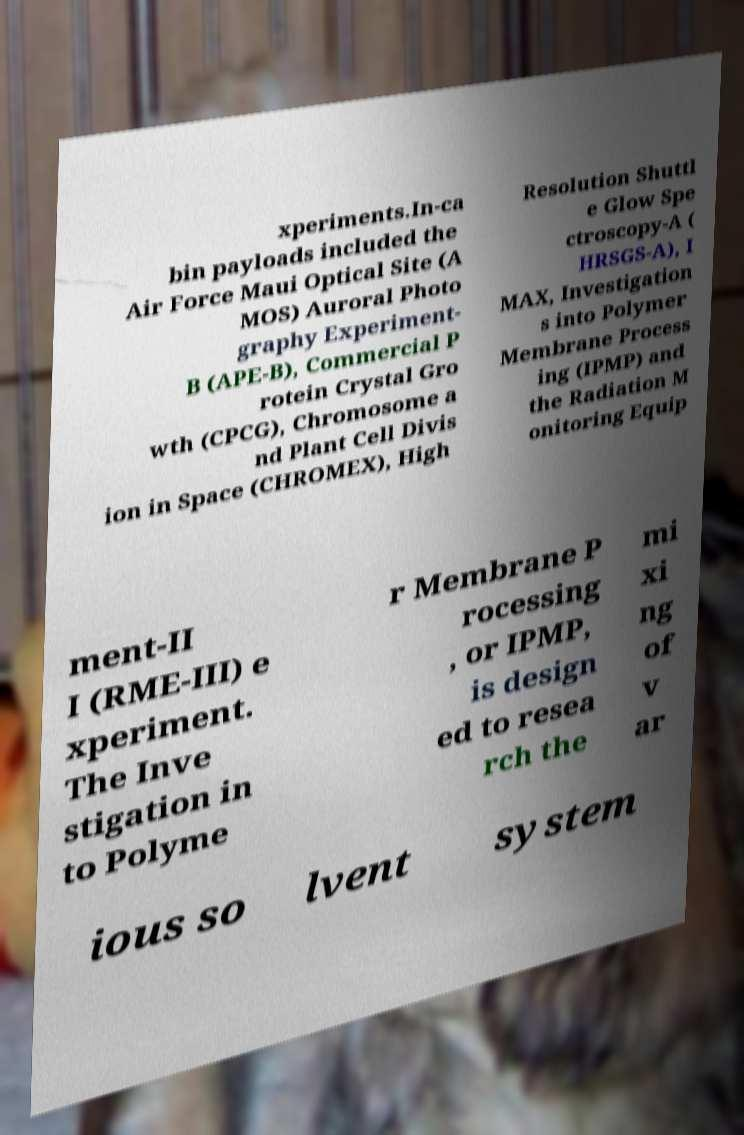For documentation purposes, I need the text within this image transcribed. Could you provide that? xperiments.In-ca bin payloads included the Air Force Maui Optical Site (A MOS) Auroral Photo graphy Experiment- B (APE-B), Commercial P rotein Crystal Gro wth (CPCG), Chromosome a nd Plant Cell Divis ion in Space (CHROMEX), High Resolution Shuttl e Glow Spe ctroscopy-A ( HRSGS-A), I MAX, Investigation s into Polymer Membrane Process ing (IPMP) and the Radiation M onitoring Equip ment-II I (RME-III) e xperiment. The Inve stigation in to Polyme r Membrane P rocessing , or IPMP, is design ed to resea rch the mi xi ng of v ar ious so lvent system 